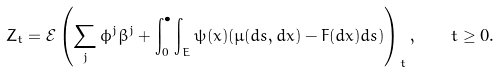<formula> <loc_0><loc_0><loc_500><loc_500>Z _ { t } = \mathcal { E } \left ( \sum _ { j } \phi ^ { j } \beta ^ { j } + \int _ { 0 } ^ { \bullet } \int _ { E } \psi ( x ) ( \mu ( d s , d x ) - F ( d x ) d s ) \right ) _ { t } , \quad t \geq 0 .</formula> 